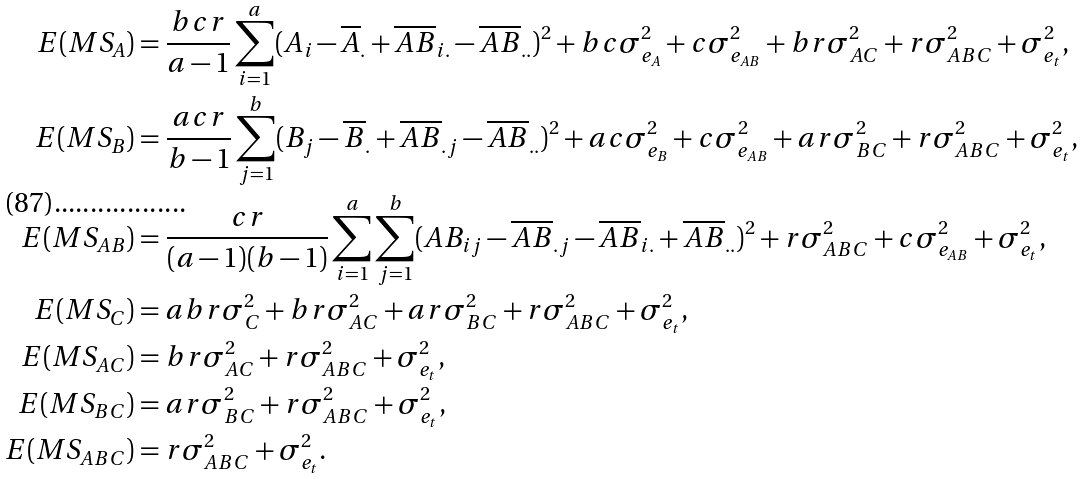Convert formula to latex. <formula><loc_0><loc_0><loc_500><loc_500>E ( M S _ { A } ) & = \frac { b c r } { a - 1 } \sum _ { i = 1 } ^ { a } ( A _ { i } - \overline { A } _ { . } + \overline { A B } _ { i . } - \overline { A B } _ { . . } ) ^ { 2 } + b c \sigma _ { e _ { A } } ^ { 2 } + c \sigma _ { e _ { A B } } ^ { 2 } + b r \sigma _ { A C } ^ { 2 } + r \sigma _ { A B C } ^ { 2 } + \sigma _ { e _ { t } } ^ { 2 } , \\ E ( M S _ { B } ) & = \frac { a c r } { b - 1 } \sum _ { j = 1 } ^ { b } ( B _ { j } - \overline { B } _ { . } + \overline { A B } _ { . j } - \overline { A B } _ { . . } ) ^ { 2 } + a c \sigma _ { e _ { B } } ^ { 2 } + c \sigma _ { e _ { A B } } ^ { 2 } + a r \sigma _ { B C } ^ { 2 } + r \sigma _ { A B C } ^ { 2 } + \sigma _ { e _ { t } } ^ { 2 } , \\ E ( M S _ { A B } ) & = \frac { c r } { ( a - 1 ) ( b - 1 ) } \sum _ { i = 1 } ^ { a } \sum _ { j = 1 } ^ { b } ( A B _ { i j } - \overline { A B } _ { . j } - \overline { A B } _ { i . } + \overline { A B } _ { . . } ) ^ { 2 } + r \sigma _ { A B C } ^ { 2 } + c \sigma _ { e _ { A B } } ^ { 2 } + \sigma _ { e _ { t } } ^ { 2 } , \\ E ( M S _ { C } ) & = a b r \sigma _ { C } ^ { 2 } + b r \sigma _ { A C } ^ { 2 } + a r \sigma _ { B C } ^ { 2 } + r \sigma _ { A B C } ^ { 2 } + \sigma _ { e _ { t } } ^ { 2 } , \\ E ( M S _ { A C } ) & = b r \sigma _ { A C } ^ { 2 } + r \sigma _ { A B C } ^ { 2 } + \sigma _ { e _ { t } } ^ { 2 } , \\ E ( M S _ { B C } ) & = a r \sigma _ { B C } ^ { 2 } + r \sigma _ { A B C } ^ { 2 } + \sigma _ { e _ { t } } ^ { 2 } , \\ E ( M S _ { A B C } ) & = r \sigma _ { A B C } ^ { 2 } + \sigma _ { e _ { t } } ^ { 2 } .</formula> 